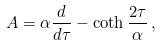<formula> <loc_0><loc_0><loc_500><loc_500>A = \alpha \frac { d } { d \tau } - \coth \frac { 2 \tau } { \alpha } \, ,</formula> 